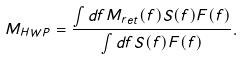Convert formula to latex. <formula><loc_0><loc_0><loc_500><loc_500>M _ { H W P } = \frac { \int d f M _ { r e t } ( f ) S ( f ) F ( f ) } { \int d f S ( f ) F ( f ) } .</formula> 